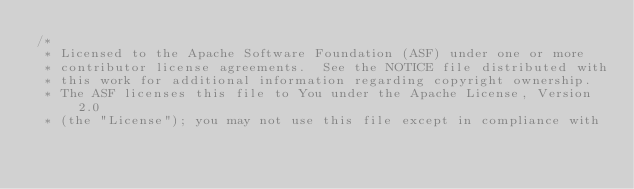<code> <loc_0><loc_0><loc_500><loc_500><_Scala_>/*
 * Licensed to the Apache Software Foundation (ASF) under one or more
 * contributor license agreements.  See the NOTICE file distributed with
 * this work for additional information regarding copyright ownership.
 * The ASF licenses this file to You under the Apache License, Version 2.0
 * (the "License"); you may not use this file except in compliance with</code> 